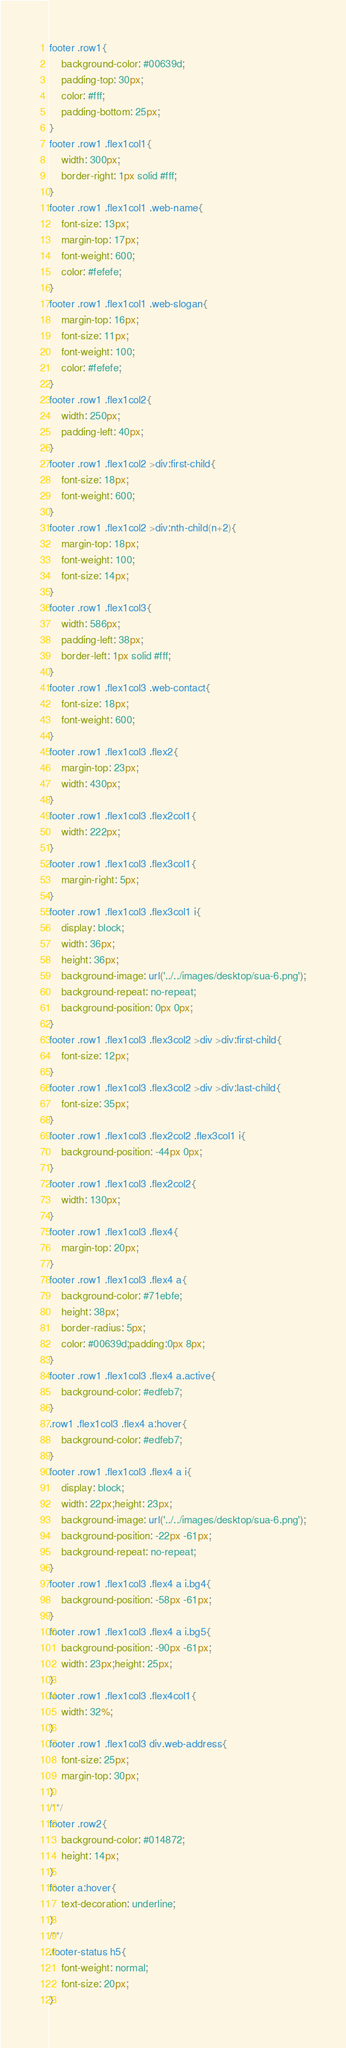<code> <loc_0><loc_0><loc_500><loc_500><_CSS_>footer .row1{
	background-color: #00639d;
	padding-top: 30px;
	color: #fff;
	padding-bottom: 25px;
}
footer .row1 .flex1col1{
	width: 300px;
	border-right: 1px solid #fff;
}
footer .row1 .flex1col1 .web-name{
	font-size: 13px;
	margin-top: 17px;
	font-weight: 600;
	color: #fefefe;
}
footer .row1 .flex1col1 .web-slogan{
	margin-top: 16px;
	font-size: 11px;
	font-weight: 100;
	color: #fefefe;
}
footer .row1 .flex1col2{
	width: 250px;
	padding-left: 40px;
}
footer .row1 .flex1col2 >div:first-child{
	font-size: 18px;
	font-weight: 600;
}
footer .row1 .flex1col2 >div:nth-child(n+2){
	margin-top: 18px;
	font-weight: 100;
	font-size: 14px;
}
footer .row1 .flex1col3{
	width: 586px;
	padding-left: 38px;
	border-left: 1px solid #fff;
}
footer .row1 .flex1col3 .web-contact{
	font-size: 18px;
	font-weight: 600;
}
footer .row1 .flex1col3 .flex2{
	margin-top: 23px;
	width: 430px;
}
footer .row1 .flex1col3 .flex2col1{
	width: 222px;
}
footer .row1 .flex1col3 .flex3col1{
	margin-right: 5px;
}
footer .row1 .flex1col3 .flex3col1 i{
	display: block;
	width: 36px;
	height: 36px;
	background-image: url('../../images/desktop/sua-6.png');
	background-repeat: no-repeat;
	background-position: 0px 0px;
}
footer .row1 .flex1col3 .flex3col2 >div >div:first-child{
	font-size: 12px;
}
footer .row1 .flex1col3 .flex3col2 >div >div:last-child{
	font-size: 35px;
}
footer .row1 .flex1col3 .flex2col2 .flex3col1 i{
	background-position: -44px 0px;
}
footer .row1 .flex1col3 .flex2col2{
	width: 130px;
}
footer .row1 .flex1col3 .flex4{
	margin-top: 20px;
}
footer .row1 .flex1col3 .flex4 a{
	background-color: #71ebfe;
	height: 38px;
	border-radius: 5px;
	color: #00639d;padding:0px 8px;
}
footer .row1 .flex1col3 .flex4 a.active{
	background-color: #edfeb7;
}
.row1 .flex1col3 .flex4 a:hover{
	background-color: #edfeb7;
}
footer .row1 .flex1col3 .flex4 a i{
	display: block;
	width: 22px;height: 23px;
	background-image: url('../../images/desktop/sua-6.png');
	background-position: -22px -61px;
	background-repeat: no-repeat;
}
footer .row1 .flex1col3 .flex4 a i.bg4{
	background-position: -58px -61px;
}
footer .row1 .flex1col3 .flex4 a i.bg5{
	background-position: -90px -61px;
	width: 23px;height: 25px;
}
footer .row1 .flex1col3 .flex4col1{
	width: 32%;
}
footer .row1 .flex1col3 div.web-address{
	font-size: 25px;
	margin-top: 30px;
}
/**/
footer .row2{
	background-color: #014872;
	height: 14px;
}
footer a:hover{
	text-decoration: underline;
}
/**/
.footer-status h5{
	font-weight: normal;
	font-size: 20px;
}</code> 